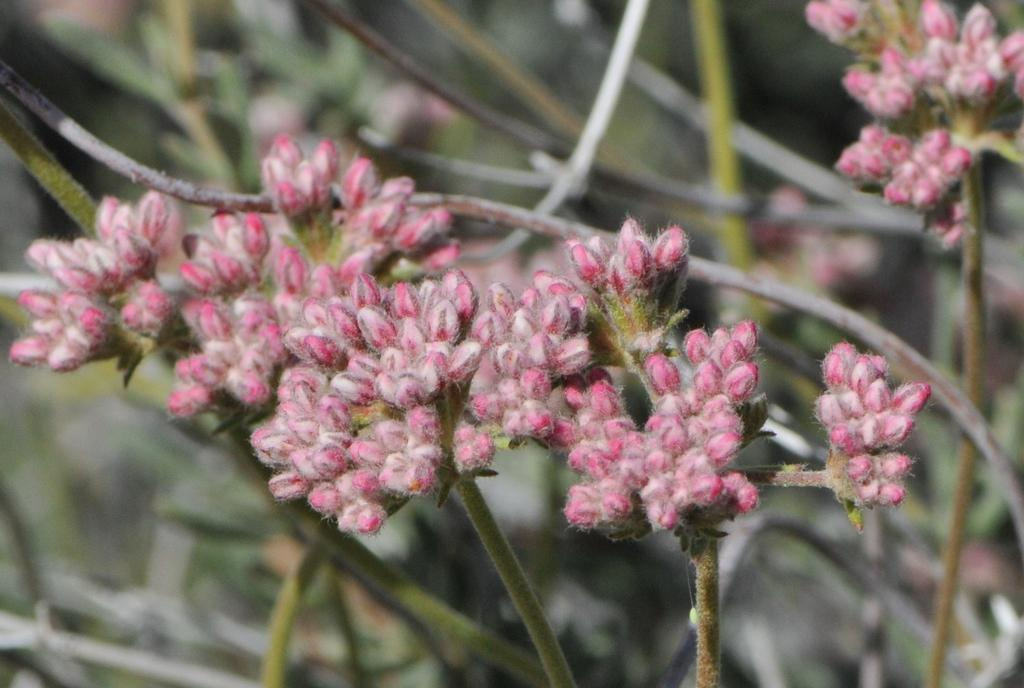What type of living organisms can be seen in the image? Plants and flowers are visible in the image. Can you describe the specific floral elements in the image? Yes, there are flowers in the image. How many fish can be seen swimming among the plants in the image? There are no fish present in the image; it features plants and flowers. What type of toys can be seen in the image? There are no toys present in the image; it features plants and flowers. 